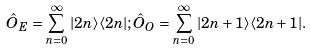Convert formula to latex. <formula><loc_0><loc_0><loc_500><loc_500>\hat { O } _ { E } = \sum _ { n = 0 } ^ { \infty } | 2 n \rangle \langle 2 n | ; \hat { O } _ { O } = \sum _ { n = 0 } ^ { \infty } | 2 n + 1 \rangle \langle 2 n + 1 | .</formula> 